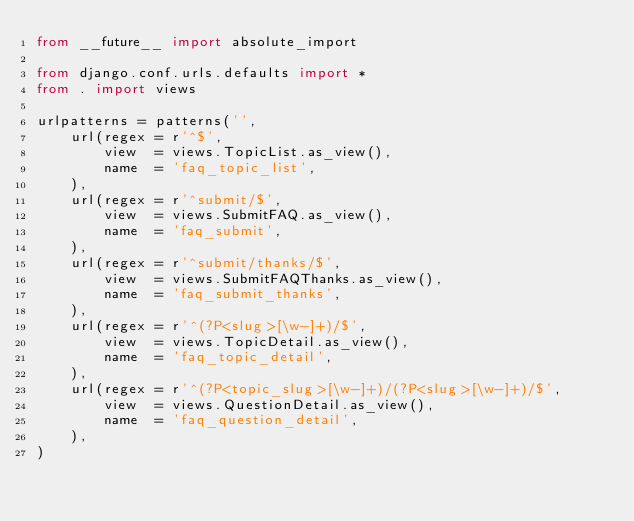<code> <loc_0><loc_0><loc_500><loc_500><_Python_>from __future__ import absolute_import

from django.conf.urls.defaults import *
from . import views

urlpatterns = patterns('',
    url(regex = r'^$',
        view  = views.TopicList.as_view(),
        name  = 'faq_topic_list',
    ),
    url(regex = r'^submit/$',
        view  = views.SubmitFAQ.as_view(),
        name  = 'faq_submit',
    ),
    url(regex = r'^submit/thanks/$',
        view  = views.SubmitFAQThanks.as_view(),
        name  = 'faq_submit_thanks',
    ),
    url(regex = r'^(?P<slug>[\w-]+)/$',
        view  = views.TopicDetail.as_view(),
        name  = 'faq_topic_detail',
    ),
    url(regex = r'^(?P<topic_slug>[\w-]+)/(?P<slug>[\w-]+)/$',
        view  = views.QuestionDetail.as_view(),
        name  = 'faq_question_detail',
    ),
)</code> 